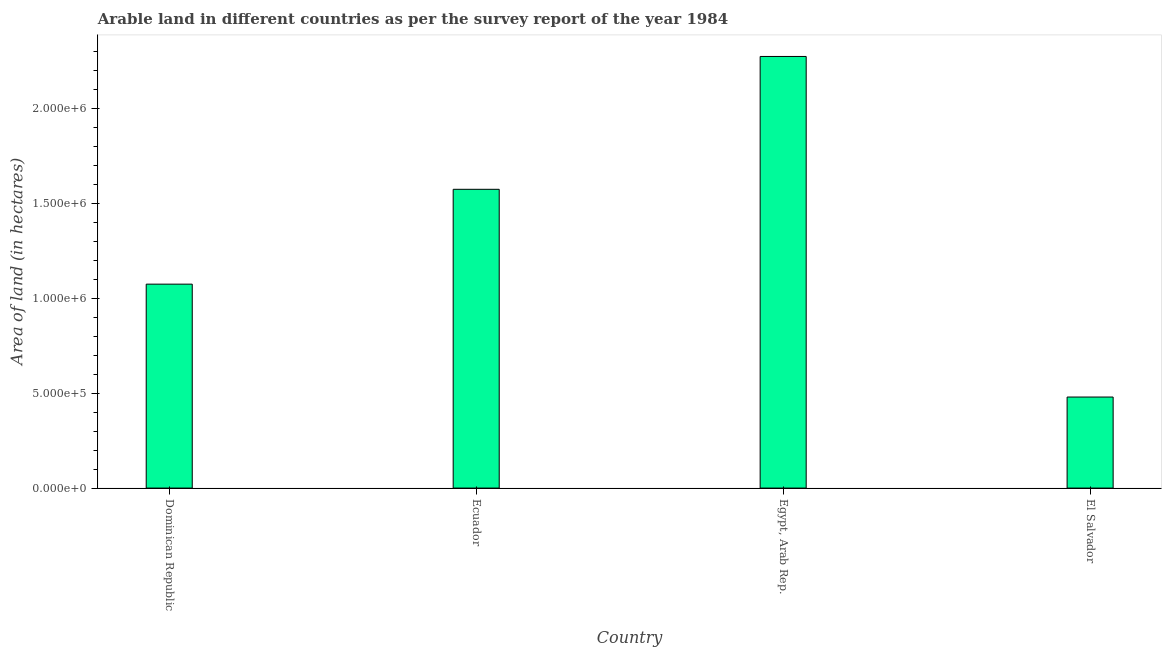Does the graph contain grids?
Offer a very short reply. No. What is the title of the graph?
Provide a succinct answer. Arable land in different countries as per the survey report of the year 1984. What is the label or title of the X-axis?
Provide a short and direct response. Country. What is the label or title of the Y-axis?
Offer a terse response. Area of land (in hectares). Across all countries, what is the maximum area of land?
Give a very brief answer. 2.28e+06. Across all countries, what is the minimum area of land?
Offer a terse response. 4.80e+05. In which country was the area of land maximum?
Keep it short and to the point. Egypt, Arab Rep. In which country was the area of land minimum?
Provide a succinct answer. El Salvador. What is the sum of the area of land?
Offer a very short reply. 5.41e+06. What is the difference between the area of land in Ecuador and Egypt, Arab Rep.?
Provide a succinct answer. -7.00e+05. What is the average area of land per country?
Offer a very short reply. 1.35e+06. What is the median area of land?
Your response must be concise. 1.32e+06. In how many countries, is the area of land greater than 200000 hectares?
Provide a succinct answer. 4. What is the ratio of the area of land in Ecuador to that in Egypt, Arab Rep.?
Your response must be concise. 0.69. Is the area of land in Egypt, Arab Rep. less than that in El Salvador?
Provide a short and direct response. No. Is the difference between the area of land in Dominican Republic and Ecuador greater than the difference between any two countries?
Offer a very short reply. No. What is the difference between the highest and the second highest area of land?
Your answer should be compact. 7.00e+05. What is the difference between the highest and the lowest area of land?
Offer a very short reply. 1.80e+06. In how many countries, is the area of land greater than the average area of land taken over all countries?
Your answer should be compact. 2. Are all the bars in the graph horizontal?
Offer a terse response. No. What is the difference between two consecutive major ticks on the Y-axis?
Provide a succinct answer. 5.00e+05. Are the values on the major ticks of Y-axis written in scientific E-notation?
Make the answer very short. Yes. What is the Area of land (in hectares) in Dominican Republic?
Keep it short and to the point. 1.08e+06. What is the Area of land (in hectares) in Ecuador?
Offer a very short reply. 1.58e+06. What is the Area of land (in hectares) of Egypt, Arab Rep.?
Your answer should be compact. 2.28e+06. What is the Area of land (in hectares) in El Salvador?
Offer a very short reply. 4.80e+05. What is the difference between the Area of land (in hectares) in Dominican Republic and Ecuador?
Provide a short and direct response. -5.00e+05. What is the difference between the Area of land (in hectares) in Dominican Republic and Egypt, Arab Rep.?
Provide a short and direct response. -1.20e+06. What is the difference between the Area of land (in hectares) in Dominican Republic and El Salvador?
Give a very brief answer. 5.95e+05. What is the difference between the Area of land (in hectares) in Ecuador and Egypt, Arab Rep.?
Keep it short and to the point. -7.00e+05. What is the difference between the Area of land (in hectares) in Ecuador and El Salvador?
Give a very brief answer. 1.10e+06. What is the difference between the Area of land (in hectares) in Egypt, Arab Rep. and El Salvador?
Offer a very short reply. 1.80e+06. What is the ratio of the Area of land (in hectares) in Dominican Republic to that in Ecuador?
Keep it short and to the point. 0.68. What is the ratio of the Area of land (in hectares) in Dominican Republic to that in Egypt, Arab Rep.?
Keep it short and to the point. 0.47. What is the ratio of the Area of land (in hectares) in Dominican Republic to that in El Salvador?
Provide a short and direct response. 2.24. What is the ratio of the Area of land (in hectares) in Ecuador to that in Egypt, Arab Rep.?
Make the answer very short. 0.69. What is the ratio of the Area of land (in hectares) in Ecuador to that in El Salvador?
Offer a very short reply. 3.28. What is the ratio of the Area of land (in hectares) in Egypt, Arab Rep. to that in El Salvador?
Keep it short and to the point. 4.74. 